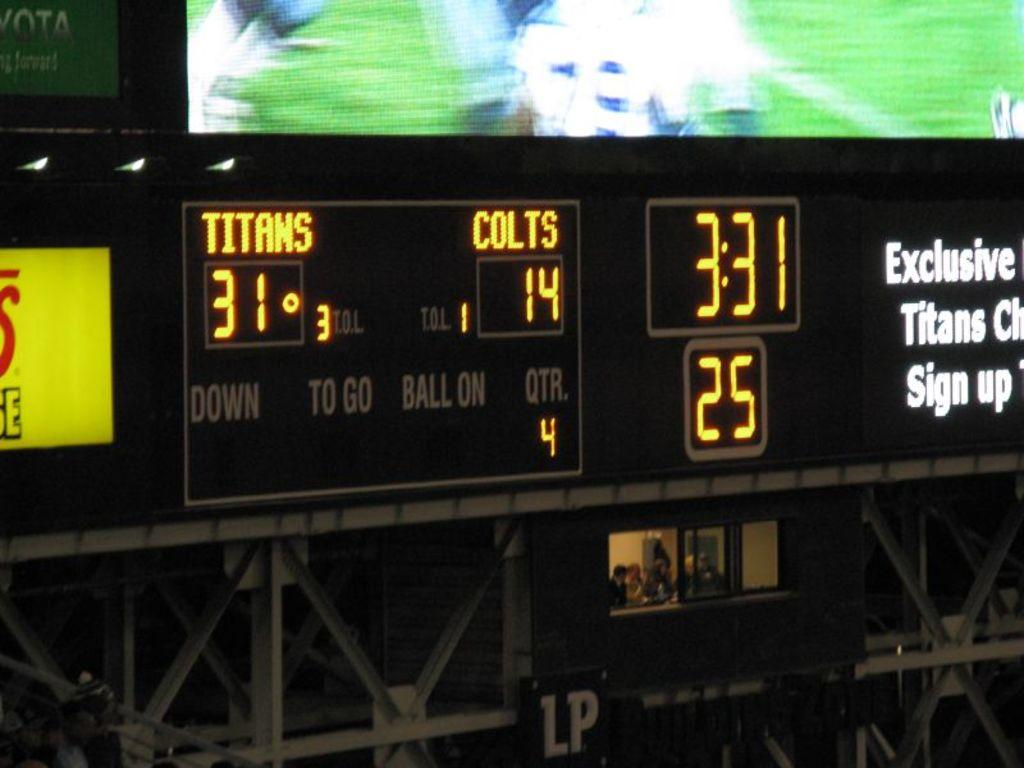<image>
Relay a brief, clear account of the picture shown. the number 25 that is on a scoreboard 